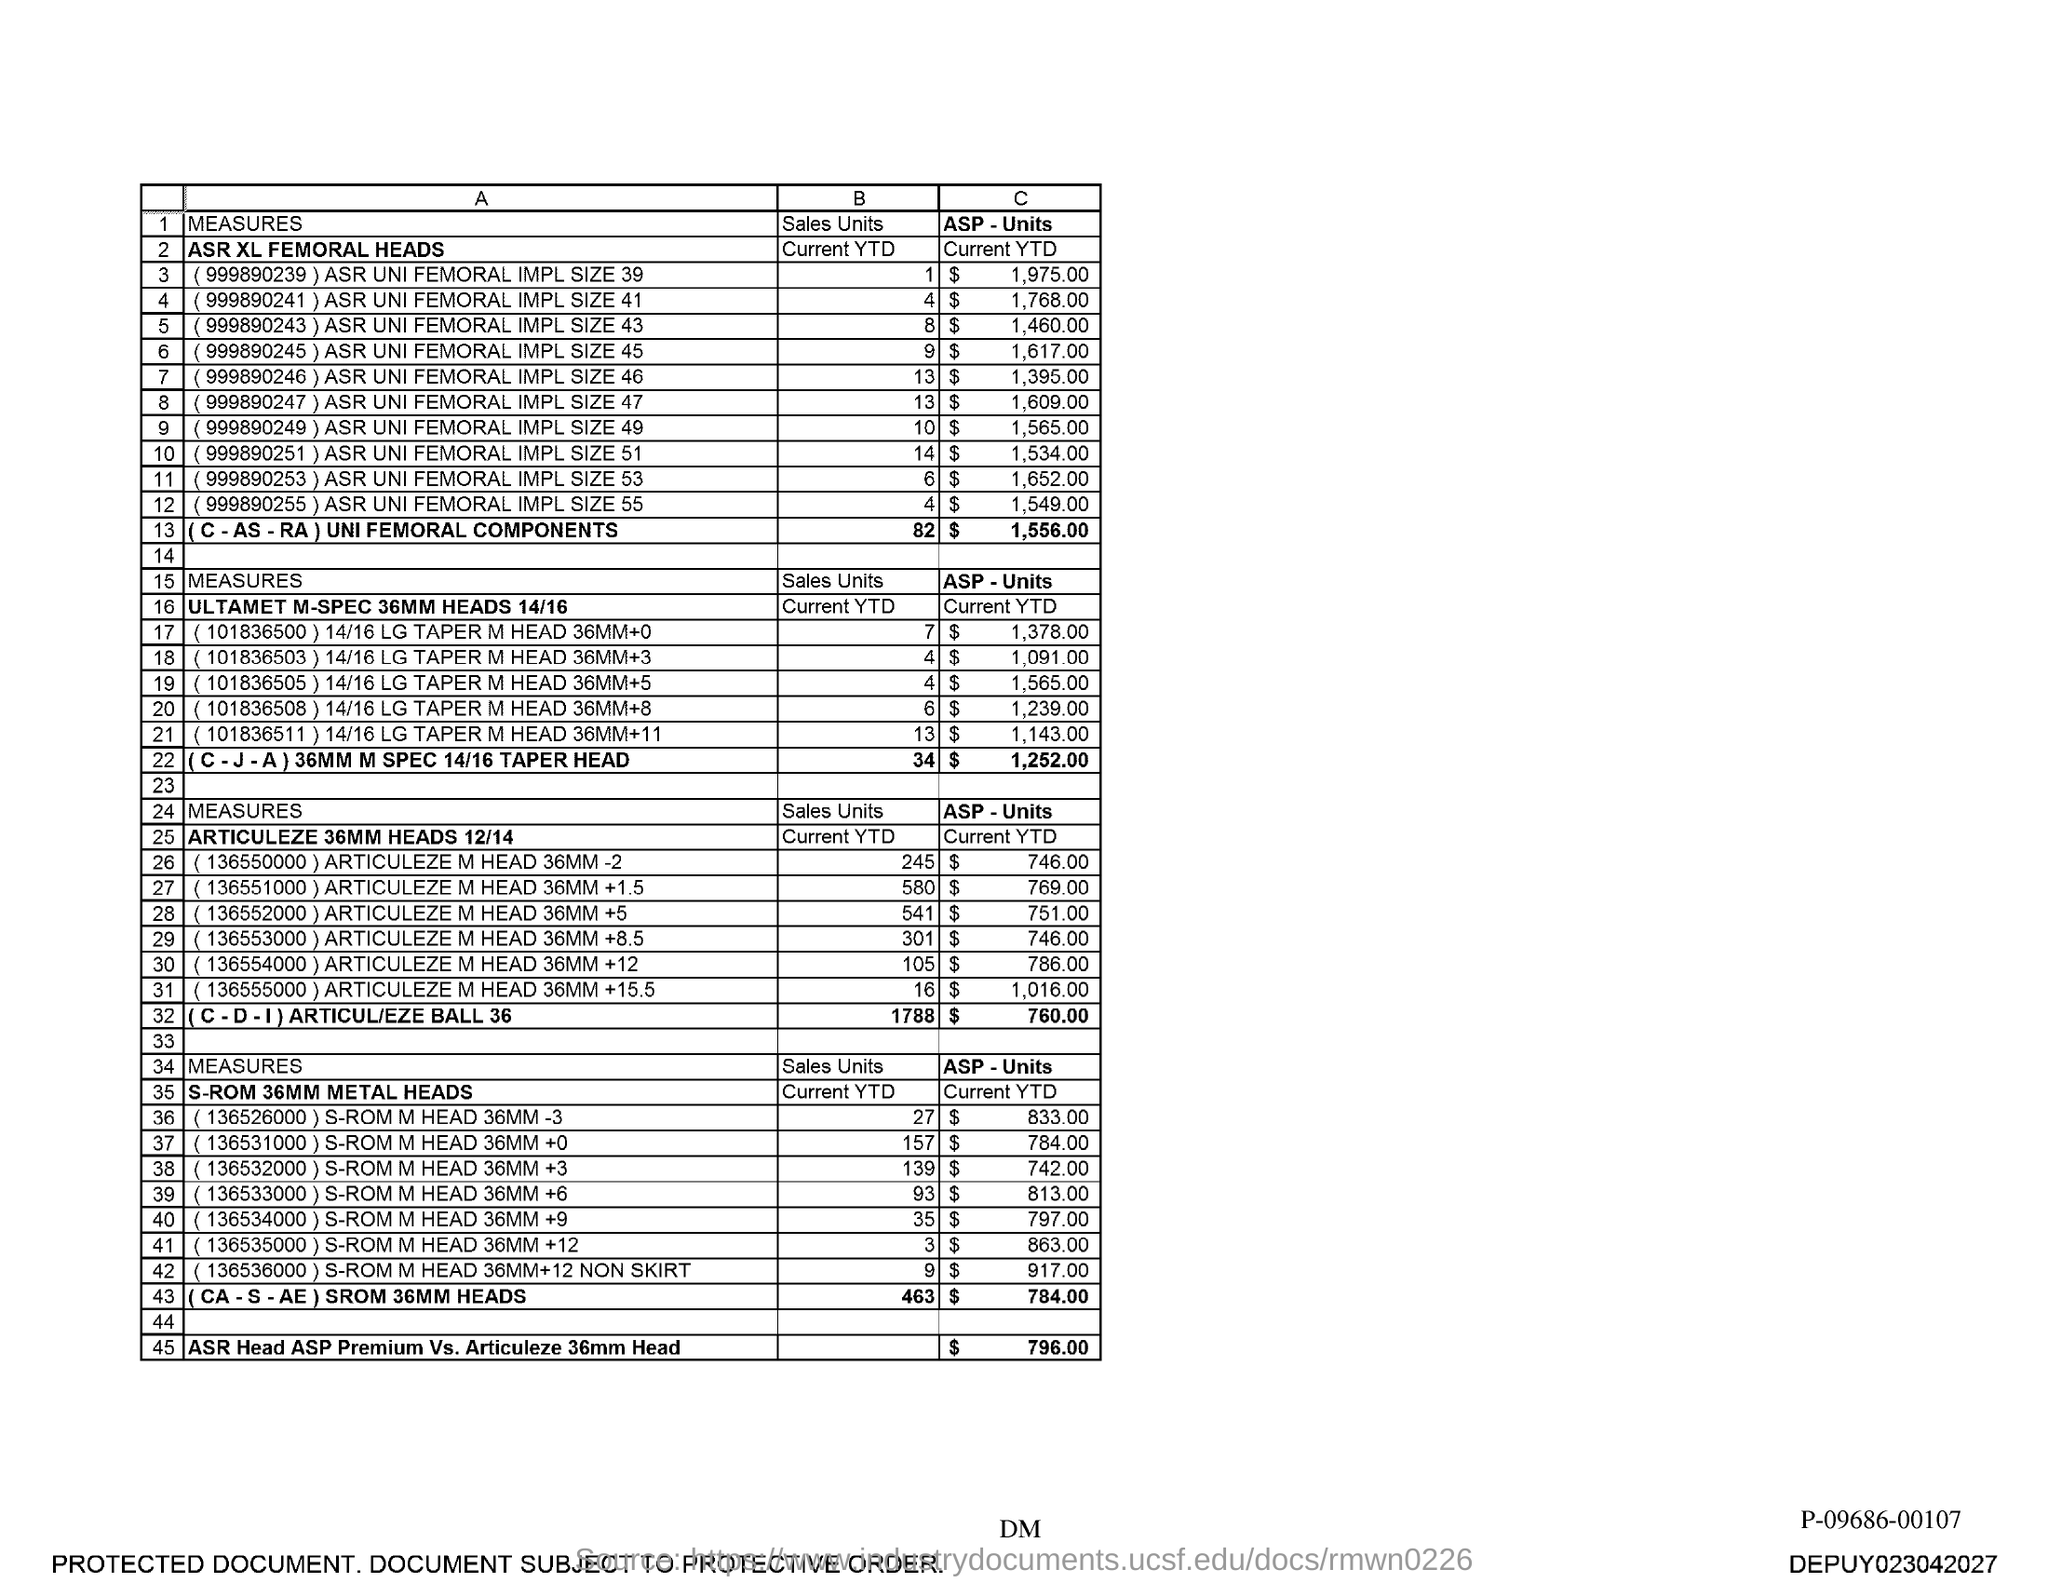Identify some key points in this picture. The ASP-Units of the ASR Head ASP Premium is compared to Articleze 36mm Head, and the cost is $796.00. 